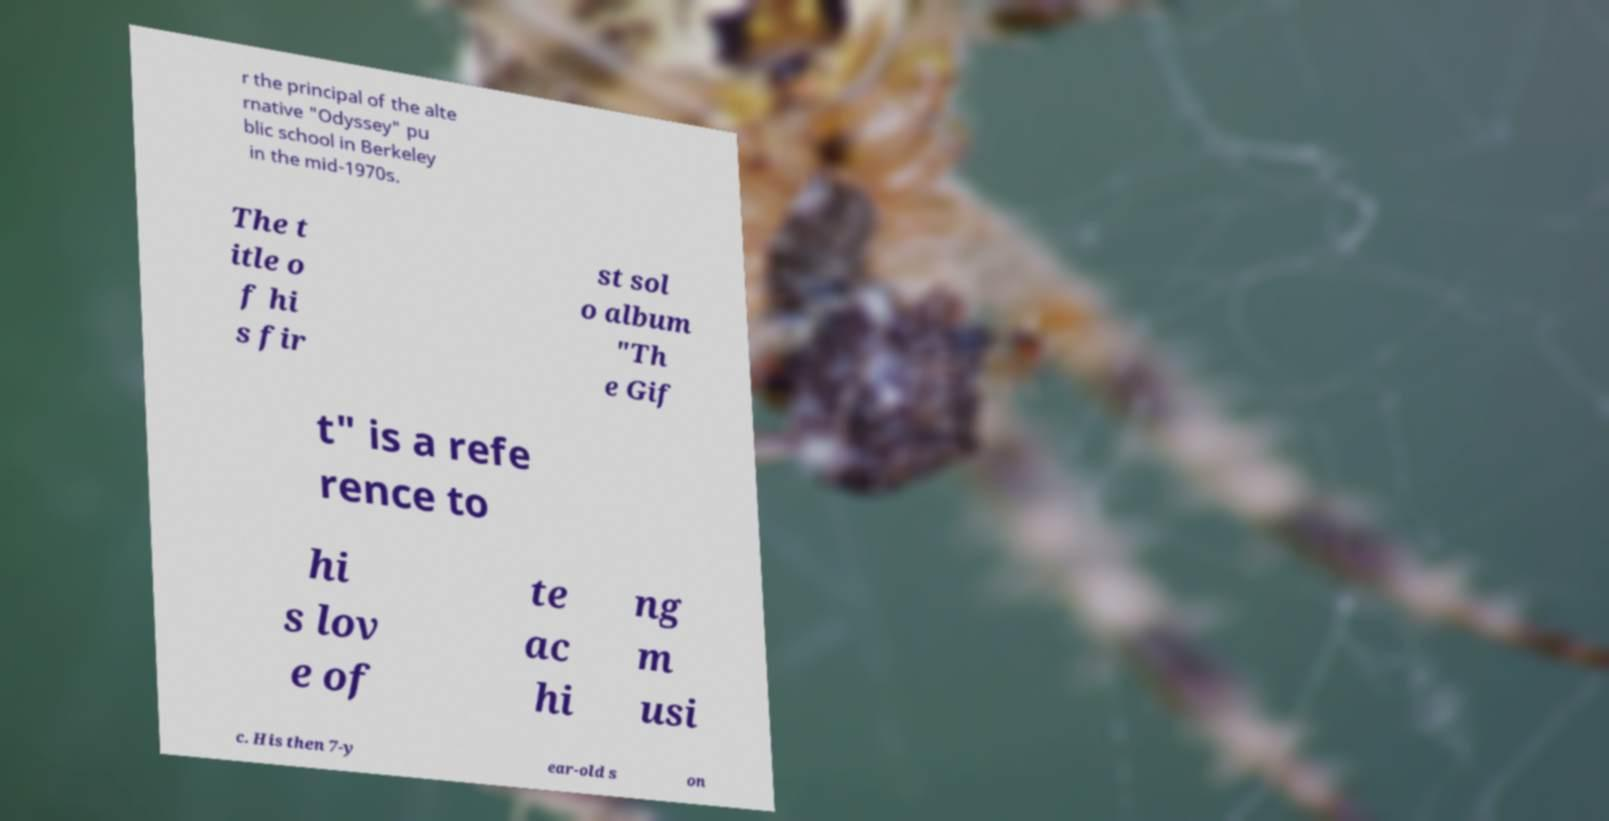Can you read and provide the text displayed in the image?This photo seems to have some interesting text. Can you extract and type it out for me? r the principal of the alte rnative "Odyssey" pu blic school in Berkeley in the mid-1970s. The t itle o f hi s fir st sol o album "Th e Gif t" is a refe rence to hi s lov e of te ac hi ng m usi c. His then 7-y ear-old s on 